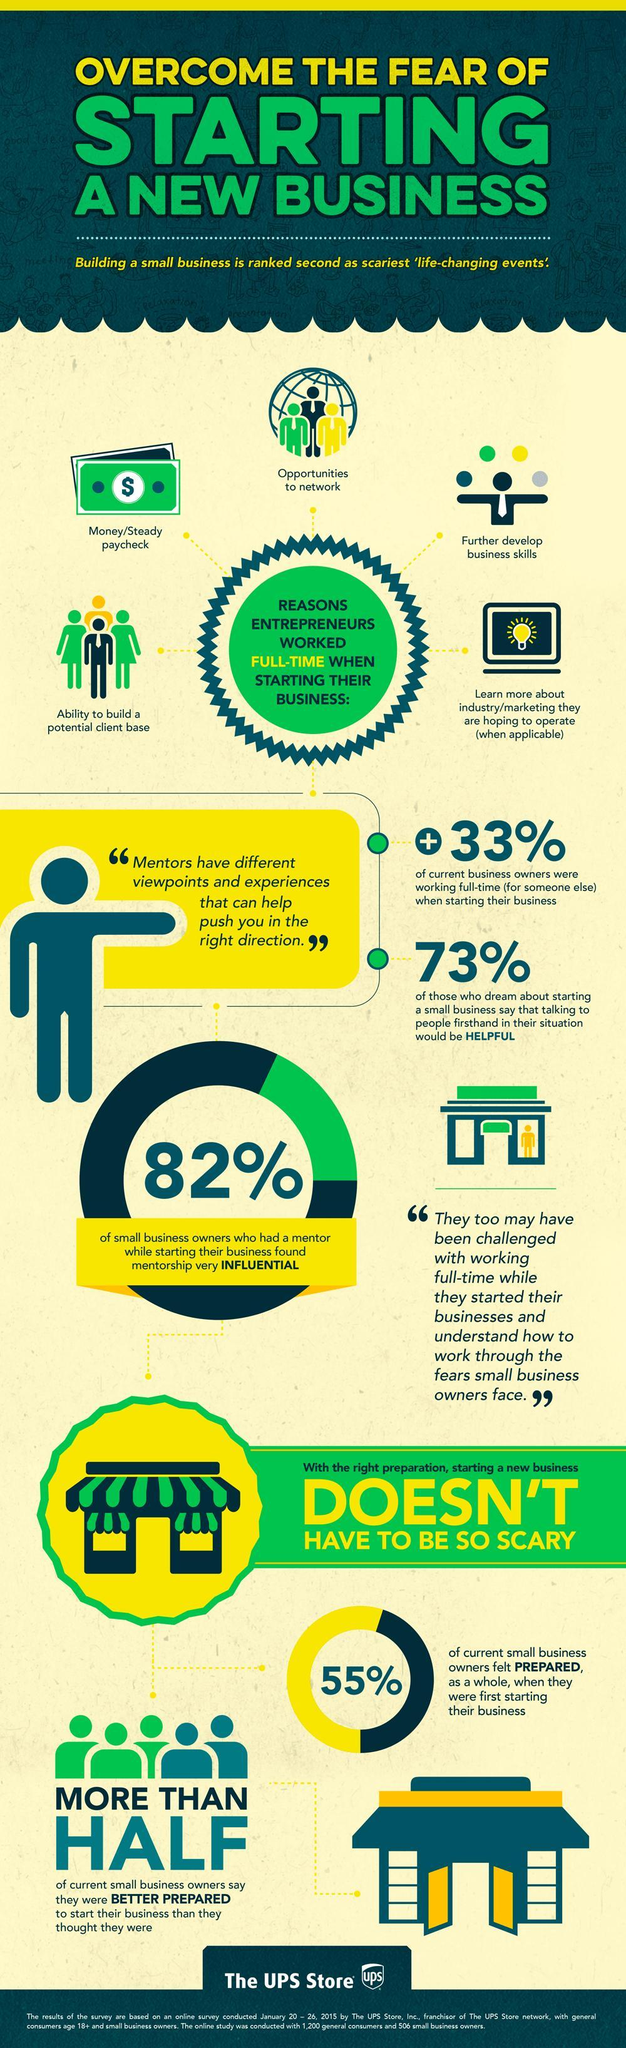What percentage of small business owners had a mentor while starting their own business?
Answer the question with a short phrase. 82% What percentage of current business owners were working full-time when starting their business? 33% 